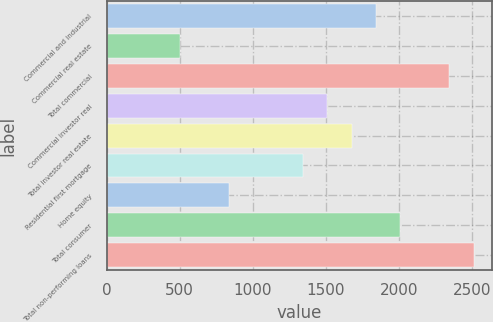<chart> <loc_0><loc_0><loc_500><loc_500><bar_chart><fcel>Commercial and industrial<fcel>Commercial real estate<fcel>Total commercial<fcel>Commercial investor real<fcel>Total investor real estate<fcel>Residential first mortgage<fcel>Home equity<fcel>Total consumer<fcel>Total non-performing loans<nl><fcel>1843.2<fcel>505.6<fcel>2344.8<fcel>1508.8<fcel>1676<fcel>1341.6<fcel>840<fcel>2010.4<fcel>2512<nl></chart> 